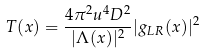Convert formula to latex. <formula><loc_0><loc_0><loc_500><loc_500>T ( x ) = \frac { 4 \pi ^ { 2 } u ^ { 4 } D ^ { 2 } } { | \Lambda ( x ) | ^ { 2 } } | g _ { L R } ( x ) | ^ { 2 }</formula> 